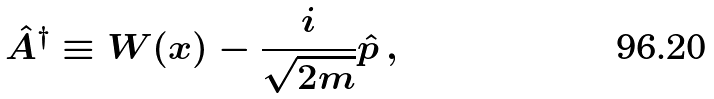Convert formula to latex. <formula><loc_0><loc_0><loc_500><loc_500>\hat { A } ^ { \dagger } \equiv W ( x ) - \frac { i } { \sqrt { 2 m } } \hat { p } \, ,</formula> 